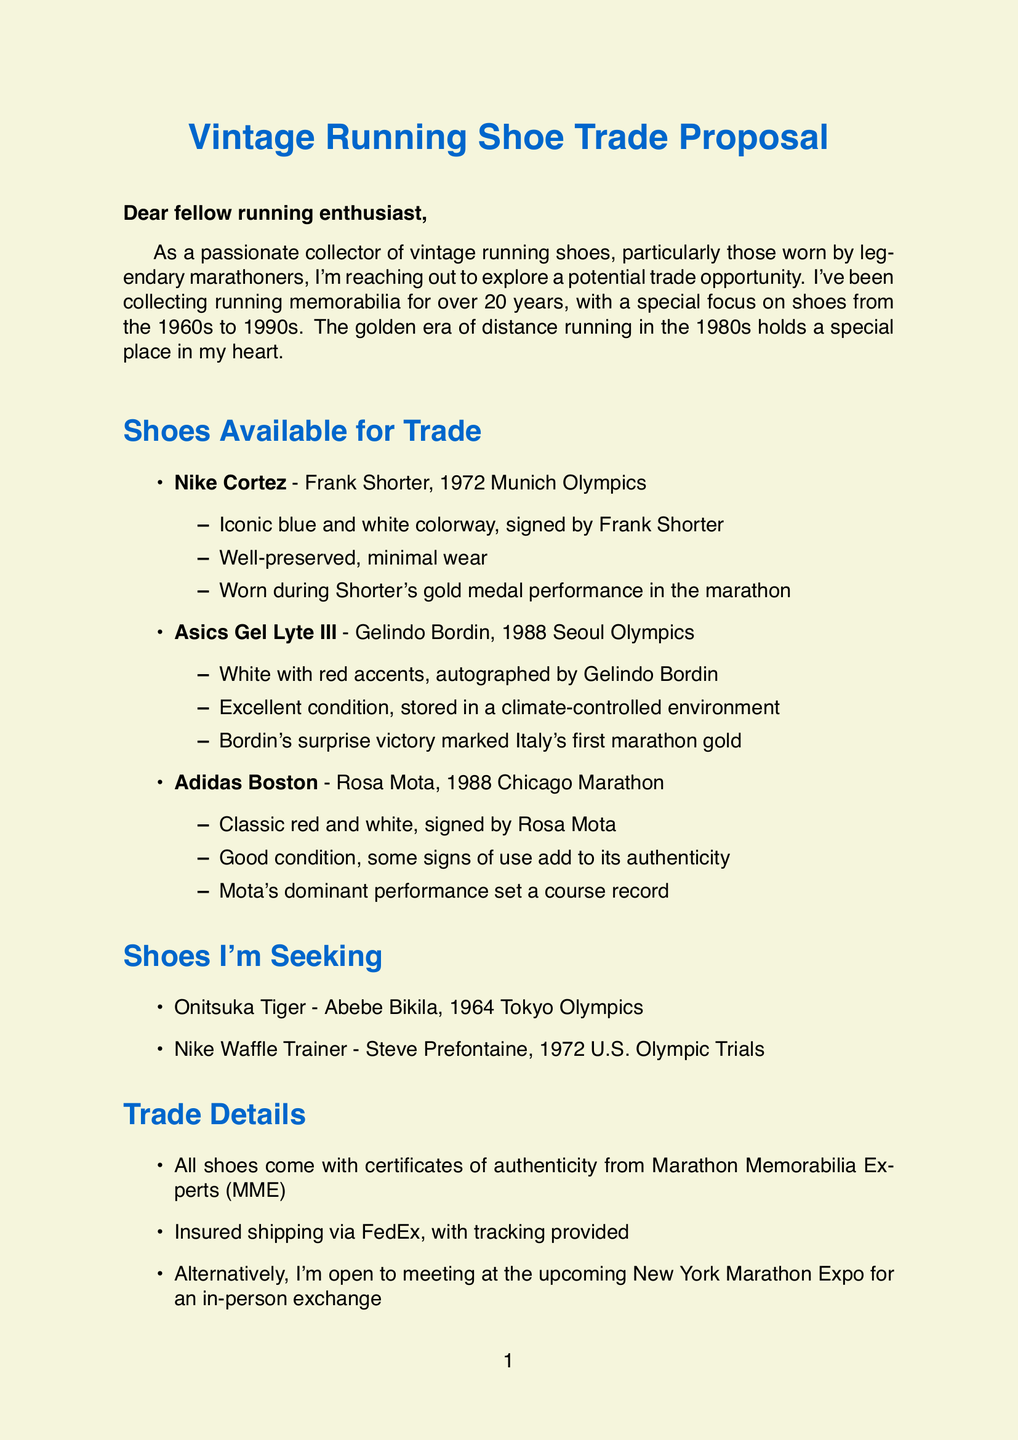What is the main purpose of the letter? The letter aims to explore a potential trade opportunity for vintage running shoes.
Answer: trade opportunity How many years has the collector been collecting memorabilia? The collector mentions they have been collecting running memorabilia for over 20 years.
Answer: over 20 years Which shoe is offered in exchange for the Nike Waffle Trainer? The letter states the collector wishes to trade the Nike Cortez for the Nike Waffle Trainer.
Answer: Nike Cortez What event did Frank Shorter wear the Nike Cortez? The document notes that Frank Shorter wore the Nike Cortez during the 1972 Munich Olympics.
Answer: 1972 Munich Olympics What is the condition of the Asics Gel Lyte III? The collector describes the condition of the Asics Gel Lyte III as excellent, stored in a climate-controlled environment.
Answer: excellent How does the collector feel about the shoes? The collector indicates that the shoes are a tangible connection to the heroes who inspired their running journey.
Answer: tangible connection What does MME stand for in the context of the trade details? MME refers to Marathon Memorabilia Experts, which provides certificates of authenticity for the shoes.
Answer: Marathon Memorabilia Experts Where is the potential in-person exchange suggested? The collector suggests meeting at the upcoming New York Marathon Expo for the exchange.
Answer: New York Marathon Expo What decade does the collector particularly admire? The collector holds a special admiration for the running scene from the 1980s.
Answer: 1980s 